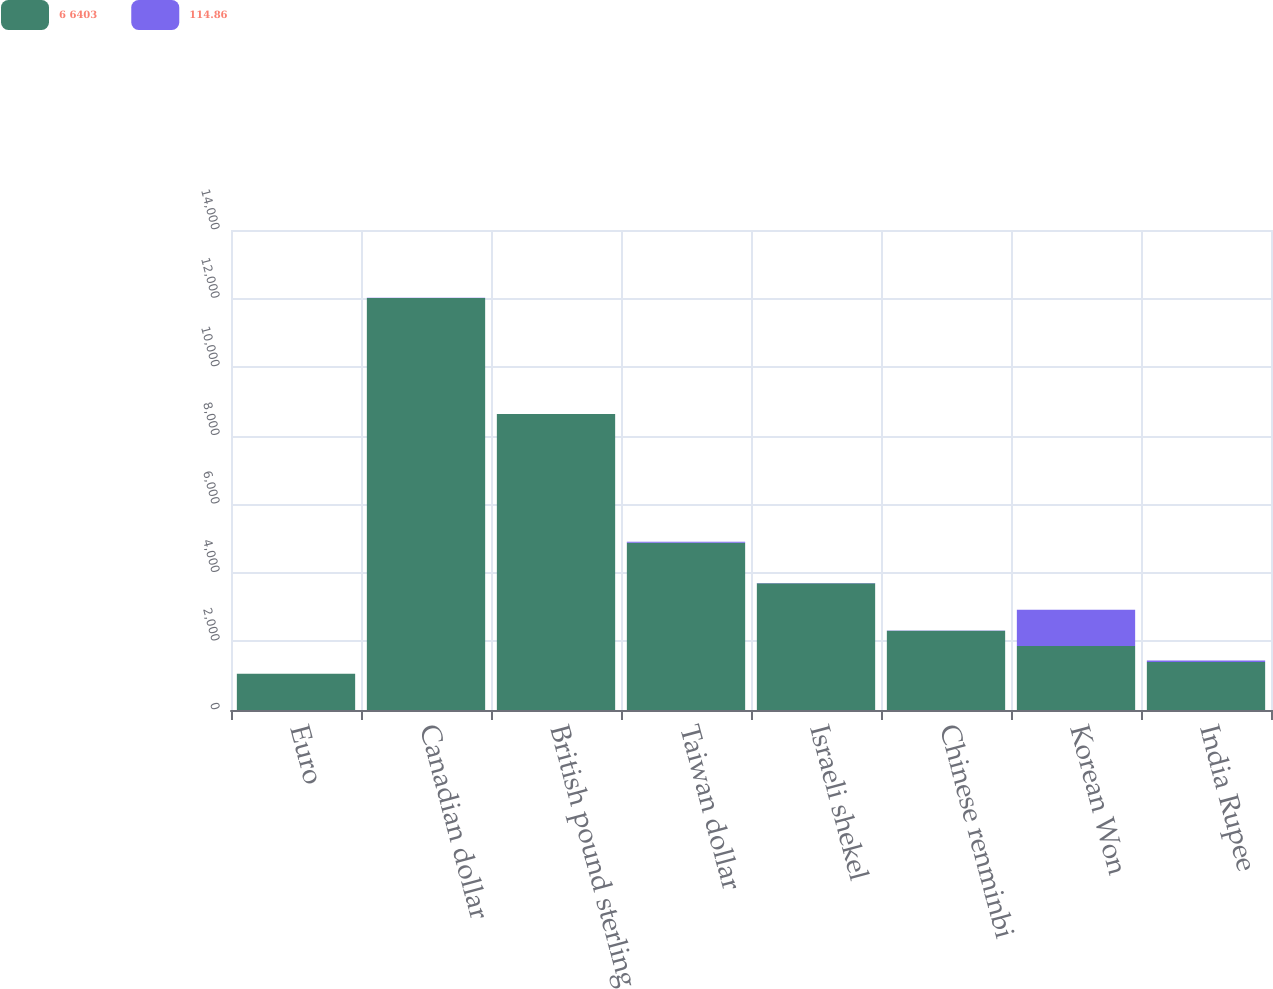Convert chart to OTSL. <chart><loc_0><loc_0><loc_500><loc_500><stacked_bar_chart><ecel><fcel>Euro<fcel>Canadian dollar<fcel>British pound sterling<fcel>Taiwan dollar<fcel>Israeli shekel<fcel>Chinese renminbi<fcel>Korean Won<fcel>India Rupee<nl><fcel>6 6403<fcel>1055.5<fcel>12020<fcel>8633<fcel>4876<fcel>3699<fcel>2314<fcel>1865<fcel>1401<nl><fcel>114.86<fcel>0.82<fcel>1.19<fcel>0.57<fcel>33.66<fcel>4.63<fcel>8.06<fcel>1055.5<fcel>45.37<nl></chart> 